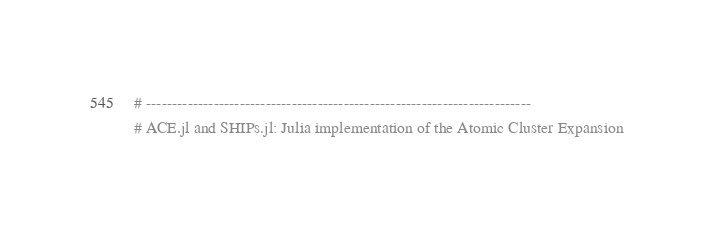Convert code to text. <code><loc_0><loc_0><loc_500><loc_500><_Julia_>
# --------------------------------------------------------------------------
# ACE.jl and SHIPs.jl: Julia implementation of the Atomic Cluster Expansion</code> 